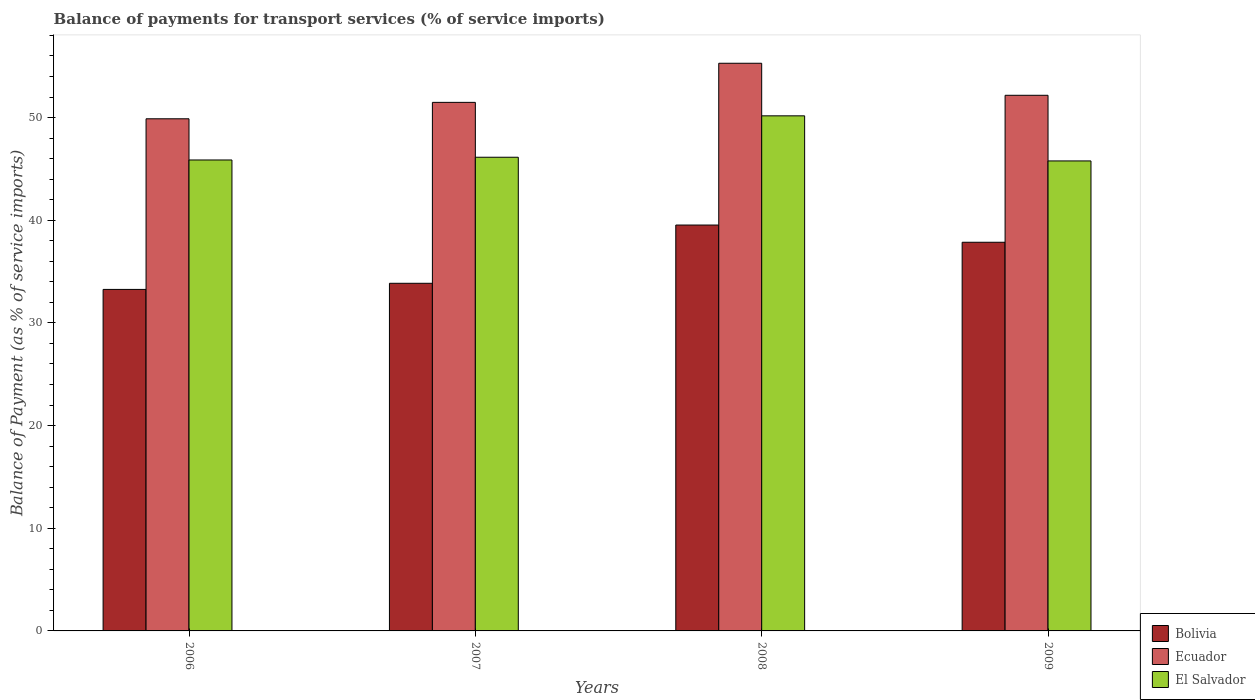Are the number of bars per tick equal to the number of legend labels?
Provide a short and direct response. Yes. Are the number of bars on each tick of the X-axis equal?
Your answer should be very brief. Yes. How many bars are there on the 2nd tick from the right?
Offer a terse response. 3. What is the label of the 3rd group of bars from the left?
Your response must be concise. 2008. In how many cases, is the number of bars for a given year not equal to the number of legend labels?
Make the answer very short. 0. What is the balance of payments for transport services in El Salvador in 2009?
Your answer should be compact. 45.78. Across all years, what is the maximum balance of payments for transport services in Ecuador?
Provide a succinct answer. 55.29. Across all years, what is the minimum balance of payments for transport services in Ecuador?
Give a very brief answer. 49.88. What is the total balance of payments for transport services in El Salvador in the graph?
Offer a terse response. 187.96. What is the difference between the balance of payments for transport services in Ecuador in 2008 and that in 2009?
Ensure brevity in your answer.  3.12. What is the difference between the balance of payments for transport services in El Salvador in 2009 and the balance of payments for transport services in Ecuador in 2006?
Keep it short and to the point. -4.11. What is the average balance of payments for transport services in Bolivia per year?
Ensure brevity in your answer.  36.13. In the year 2006, what is the difference between the balance of payments for transport services in El Salvador and balance of payments for transport services in Ecuador?
Your answer should be very brief. -4.01. What is the ratio of the balance of payments for transport services in Bolivia in 2006 to that in 2008?
Provide a succinct answer. 0.84. Is the balance of payments for transport services in Ecuador in 2006 less than that in 2008?
Ensure brevity in your answer.  Yes. What is the difference between the highest and the second highest balance of payments for transport services in El Salvador?
Offer a very short reply. 4.03. What is the difference between the highest and the lowest balance of payments for transport services in El Salvador?
Provide a succinct answer. 4.39. What does the 2nd bar from the left in 2008 represents?
Make the answer very short. Ecuador. How many bars are there?
Give a very brief answer. 12. Are all the bars in the graph horizontal?
Offer a very short reply. No. How many years are there in the graph?
Make the answer very short. 4. What is the difference between two consecutive major ticks on the Y-axis?
Offer a terse response. 10. Are the values on the major ticks of Y-axis written in scientific E-notation?
Ensure brevity in your answer.  No. Does the graph contain any zero values?
Ensure brevity in your answer.  No. Where does the legend appear in the graph?
Keep it short and to the point. Bottom right. How are the legend labels stacked?
Offer a very short reply. Vertical. What is the title of the graph?
Offer a very short reply. Balance of payments for transport services (% of service imports). What is the label or title of the X-axis?
Your answer should be very brief. Years. What is the label or title of the Y-axis?
Your answer should be very brief. Balance of Payment (as % of service imports). What is the Balance of Payment (as % of service imports) in Bolivia in 2006?
Ensure brevity in your answer.  33.26. What is the Balance of Payment (as % of service imports) of Ecuador in 2006?
Your answer should be very brief. 49.88. What is the Balance of Payment (as % of service imports) in El Salvador in 2006?
Keep it short and to the point. 45.87. What is the Balance of Payment (as % of service imports) of Bolivia in 2007?
Offer a terse response. 33.86. What is the Balance of Payment (as % of service imports) of Ecuador in 2007?
Make the answer very short. 51.48. What is the Balance of Payment (as % of service imports) of El Salvador in 2007?
Your response must be concise. 46.14. What is the Balance of Payment (as % of service imports) in Bolivia in 2008?
Offer a terse response. 39.53. What is the Balance of Payment (as % of service imports) of Ecuador in 2008?
Make the answer very short. 55.29. What is the Balance of Payment (as % of service imports) of El Salvador in 2008?
Offer a terse response. 50.17. What is the Balance of Payment (as % of service imports) of Bolivia in 2009?
Make the answer very short. 37.86. What is the Balance of Payment (as % of service imports) in Ecuador in 2009?
Offer a very short reply. 52.17. What is the Balance of Payment (as % of service imports) in El Salvador in 2009?
Offer a very short reply. 45.78. Across all years, what is the maximum Balance of Payment (as % of service imports) in Bolivia?
Keep it short and to the point. 39.53. Across all years, what is the maximum Balance of Payment (as % of service imports) in Ecuador?
Offer a terse response. 55.29. Across all years, what is the maximum Balance of Payment (as % of service imports) of El Salvador?
Keep it short and to the point. 50.17. Across all years, what is the minimum Balance of Payment (as % of service imports) of Bolivia?
Provide a succinct answer. 33.26. Across all years, what is the minimum Balance of Payment (as % of service imports) in Ecuador?
Offer a terse response. 49.88. Across all years, what is the minimum Balance of Payment (as % of service imports) in El Salvador?
Your response must be concise. 45.78. What is the total Balance of Payment (as % of service imports) in Bolivia in the graph?
Your response must be concise. 144.52. What is the total Balance of Payment (as % of service imports) of Ecuador in the graph?
Ensure brevity in your answer.  208.83. What is the total Balance of Payment (as % of service imports) in El Salvador in the graph?
Make the answer very short. 187.96. What is the difference between the Balance of Payment (as % of service imports) of Bolivia in 2006 and that in 2007?
Make the answer very short. -0.6. What is the difference between the Balance of Payment (as % of service imports) of Ecuador in 2006 and that in 2007?
Provide a short and direct response. -1.6. What is the difference between the Balance of Payment (as % of service imports) in El Salvador in 2006 and that in 2007?
Give a very brief answer. -0.27. What is the difference between the Balance of Payment (as % of service imports) in Bolivia in 2006 and that in 2008?
Ensure brevity in your answer.  -6.27. What is the difference between the Balance of Payment (as % of service imports) in Ecuador in 2006 and that in 2008?
Ensure brevity in your answer.  -5.41. What is the difference between the Balance of Payment (as % of service imports) in El Salvador in 2006 and that in 2008?
Ensure brevity in your answer.  -4.3. What is the difference between the Balance of Payment (as % of service imports) in Bolivia in 2006 and that in 2009?
Ensure brevity in your answer.  -4.59. What is the difference between the Balance of Payment (as % of service imports) in Ecuador in 2006 and that in 2009?
Make the answer very short. -2.29. What is the difference between the Balance of Payment (as % of service imports) of El Salvador in 2006 and that in 2009?
Provide a succinct answer. 0.09. What is the difference between the Balance of Payment (as % of service imports) in Bolivia in 2007 and that in 2008?
Provide a succinct answer. -5.67. What is the difference between the Balance of Payment (as % of service imports) in Ecuador in 2007 and that in 2008?
Offer a terse response. -3.81. What is the difference between the Balance of Payment (as % of service imports) in El Salvador in 2007 and that in 2008?
Offer a very short reply. -4.03. What is the difference between the Balance of Payment (as % of service imports) of Bolivia in 2007 and that in 2009?
Ensure brevity in your answer.  -4. What is the difference between the Balance of Payment (as % of service imports) in Ecuador in 2007 and that in 2009?
Provide a succinct answer. -0.69. What is the difference between the Balance of Payment (as % of service imports) of El Salvador in 2007 and that in 2009?
Make the answer very short. 0.36. What is the difference between the Balance of Payment (as % of service imports) in Bolivia in 2008 and that in 2009?
Provide a succinct answer. 1.68. What is the difference between the Balance of Payment (as % of service imports) of Ecuador in 2008 and that in 2009?
Your answer should be very brief. 3.12. What is the difference between the Balance of Payment (as % of service imports) of El Salvador in 2008 and that in 2009?
Your answer should be very brief. 4.39. What is the difference between the Balance of Payment (as % of service imports) of Bolivia in 2006 and the Balance of Payment (as % of service imports) of Ecuador in 2007?
Offer a very short reply. -18.22. What is the difference between the Balance of Payment (as % of service imports) in Bolivia in 2006 and the Balance of Payment (as % of service imports) in El Salvador in 2007?
Your answer should be compact. -12.87. What is the difference between the Balance of Payment (as % of service imports) of Ecuador in 2006 and the Balance of Payment (as % of service imports) of El Salvador in 2007?
Your answer should be very brief. 3.75. What is the difference between the Balance of Payment (as % of service imports) of Bolivia in 2006 and the Balance of Payment (as % of service imports) of Ecuador in 2008?
Keep it short and to the point. -22.03. What is the difference between the Balance of Payment (as % of service imports) of Bolivia in 2006 and the Balance of Payment (as % of service imports) of El Salvador in 2008?
Your answer should be compact. -16.91. What is the difference between the Balance of Payment (as % of service imports) of Ecuador in 2006 and the Balance of Payment (as % of service imports) of El Salvador in 2008?
Give a very brief answer. -0.29. What is the difference between the Balance of Payment (as % of service imports) of Bolivia in 2006 and the Balance of Payment (as % of service imports) of Ecuador in 2009?
Offer a terse response. -18.91. What is the difference between the Balance of Payment (as % of service imports) of Bolivia in 2006 and the Balance of Payment (as % of service imports) of El Salvador in 2009?
Give a very brief answer. -12.51. What is the difference between the Balance of Payment (as % of service imports) of Ecuador in 2006 and the Balance of Payment (as % of service imports) of El Salvador in 2009?
Give a very brief answer. 4.11. What is the difference between the Balance of Payment (as % of service imports) of Bolivia in 2007 and the Balance of Payment (as % of service imports) of Ecuador in 2008?
Provide a short and direct response. -21.43. What is the difference between the Balance of Payment (as % of service imports) in Bolivia in 2007 and the Balance of Payment (as % of service imports) in El Salvador in 2008?
Make the answer very short. -16.31. What is the difference between the Balance of Payment (as % of service imports) of Ecuador in 2007 and the Balance of Payment (as % of service imports) of El Salvador in 2008?
Offer a very short reply. 1.31. What is the difference between the Balance of Payment (as % of service imports) in Bolivia in 2007 and the Balance of Payment (as % of service imports) in Ecuador in 2009?
Keep it short and to the point. -18.31. What is the difference between the Balance of Payment (as % of service imports) in Bolivia in 2007 and the Balance of Payment (as % of service imports) in El Salvador in 2009?
Provide a short and direct response. -11.92. What is the difference between the Balance of Payment (as % of service imports) of Ecuador in 2007 and the Balance of Payment (as % of service imports) of El Salvador in 2009?
Offer a very short reply. 5.7. What is the difference between the Balance of Payment (as % of service imports) of Bolivia in 2008 and the Balance of Payment (as % of service imports) of Ecuador in 2009?
Ensure brevity in your answer.  -12.64. What is the difference between the Balance of Payment (as % of service imports) of Bolivia in 2008 and the Balance of Payment (as % of service imports) of El Salvador in 2009?
Provide a short and direct response. -6.24. What is the difference between the Balance of Payment (as % of service imports) in Ecuador in 2008 and the Balance of Payment (as % of service imports) in El Salvador in 2009?
Give a very brief answer. 9.51. What is the average Balance of Payment (as % of service imports) of Bolivia per year?
Keep it short and to the point. 36.13. What is the average Balance of Payment (as % of service imports) in Ecuador per year?
Offer a very short reply. 52.21. What is the average Balance of Payment (as % of service imports) of El Salvador per year?
Your answer should be very brief. 46.99. In the year 2006, what is the difference between the Balance of Payment (as % of service imports) in Bolivia and Balance of Payment (as % of service imports) in Ecuador?
Provide a succinct answer. -16.62. In the year 2006, what is the difference between the Balance of Payment (as % of service imports) of Bolivia and Balance of Payment (as % of service imports) of El Salvador?
Offer a terse response. -12.61. In the year 2006, what is the difference between the Balance of Payment (as % of service imports) in Ecuador and Balance of Payment (as % of service imports) in El Salvador?
Keep it short and to the point. 4.01. In the year 2007, what is the difference between the Balance of Payment (as % of service imports) of Bolivia and Balance of Payment (as % of service imports) of Ecuador?
Provide a succinct answer. -17.62. In the year 2007, what is the difference between the Balance of Payment (as % of service imports) in Bolivia and Balance of Payment (as % of service imports) in El Salvador?
Keep it short and to the point. -12.28. In the year 2007, what is the difference between the Balance of Payment (as % of service imports) in Ecuador and Balance of Payment (as % of service imports) in El Salvador?
Provide a short and direct response. 5.34. In the year 2008, what is the difference between the Balance of Payment (as % of service imports) in Bolivia and Balance of Payment (as % of service imports) in Ecuador?
Ensure brevity in your answer.  -15.76. In the year 2008, what is the difference between the Balance of Payment (as % of service imports) of Bolivia and Balance of Payment (as % of service imports) of El Salvador?
Your answer should be very brief. -10.64. In the year 2008, what is the difference between the Balance of Payment (as % of service imports) in Ecuador and Balance of Payment (as % of service imports) in El Salvador?
Your response must be concise. 5.12. In the year 2009, what is the difference between the Balance of Payment (as % of service imports) of Bolivia and Balance of Payment (as % of service imports) of Ecuador?
Keep it short and to the point. -14.31. In the year 2009, what is the difference between the Balance of Payment (as % of service imports) in Bolivia and Balance of Payment (as % of service imports) in El Salvador?
Your answer should be very brief. -7.92. In the year 2009, what is the difference between the Balance of Payment (as % of service imports) of Ecuador and Balance of Payment (as % of service imports) of El Salvador?
Your answer should be compact. 6.39. What is the ratio of the Balance of Payment (as % of service imports) in Bolivia in 2006 to that in 2007?
Keep it short and to the point. 0.98. What is the ratio of the Balance of Payment (as % of service imports) in Ecuador in 2006 to that in 2007?
Ensure brevity in your answer.  0.97. What is the ratio of the Balance of Payment (as % of service imports) in El Salvador in 2006 to that in 2007?
Give a very brief answer. 0.99. What is the ratio of the Balance of Payment (as % of service imports) of Bolivia in 2006 to that in 2008?
Your answer should be very brief. 0.84. What is the ratio of the Balance of Payment (as % of service imports) in Ecuador in 2006 to that in 2008?
Provide a short and direct response. 0.9. What is the ratio of the Balance of Payment (as % of service imports) in El Salvador in 2006 to that in 2008?
Your response must be concise. 0.91. What is the ratio of the Balance of Payment (as % of service imports) of Bolivia in 2006 to that in 2009?
Your response must be concise. 0.88. What is the ratio of the Balance of Payment (as % of service imports) in Ecuador in 2006 to that in 2009?
Offer a terse response. 0.96. What is the ratio of the Balance of Payment (as % of service imports) in El Salvador in 2006 to that in 2009?
Ensure brevity in your answer.  1. What is the ratio of the Balance of Payment (as % of service imports) of Bolivia in 2007 to that in 2008?
Provide a short and direct response. 0.86. What is the ratio of the Balance of Payment (as % of service imports) in Ecuador in 2007 to that in 2008?
Offer a very short reply. 0.93. What is the ratio of the Balance of Payment (as % of service imports) in El Salvador in 2007 to that in 2008?
Your response must be concise. 0.92. What is the ratio of the Balance of Payment (as % of service imports) in Bolivia in 2007 to that in 2009?
Offer a terse response. 0.89. What is the ratio of the Balance of Payment (as % of service imports) in Bolivia in 2008 to that in 2009?
Provide a succinct answer. 1.04. What is the ratio of the Balance of Payment (as % of service imports) in Ecuador in 2008 to that in 2009?
Provide a short and direct response. 1.06. What is the ratio of the Balance of Payment (as % of service imports) of El Salvador in 2008 to that in 2009?
Your response must be concise. 1.1. What is the difference between the highest and the second highest Balance of Payment (as % of service imports) in Bolivia?
Offer a terse response. 1.68. What is the difference between the highest and the second highest Balance of Payment (as % of service imports) in Ecuador?
Your response must be concise. 3.12. What is the difference between the highest and the second highest Balance of Payment (as % of service imports) of El Salvador?
Give a very brief answer. 4.03. What is the difference between the highest and the lowest Balance of Payment (as % of service imports) in Bolivia?
Your answer should be very brief. 6.27. What is the difference between the highest and the lowest Balance of Payment (as % of service imports) of Ecuador?
Offer a terse response. 5.41. What is the difference between the highest and the lowest Balance of Payment (as % of service imports) of El Salvador?
Offer a very short reply. 4.39. 